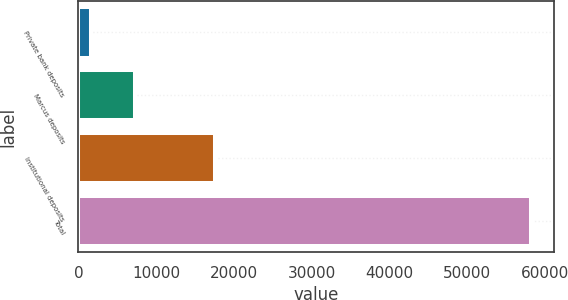Convert chart to OTSL. <chart><loc_0><loc_0><loc_500><loc_500><bar_chart><fcel>Private bank deposits<fcel>Marcus deposits<fcel>Institutional deposits<fcel>Total<nl><fcel>1623<fcel>7282.5<fcel>17561<fcel>58218<nl></chart> 